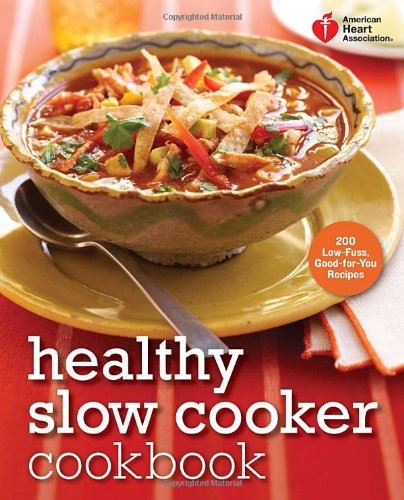Who is the author of this book? The book highlighted in the image, titled 'Healthy Slow Cooker Cookbook', is authored by the American Heart Association, a renowned organization committed to fighting heart disease and stroke. 